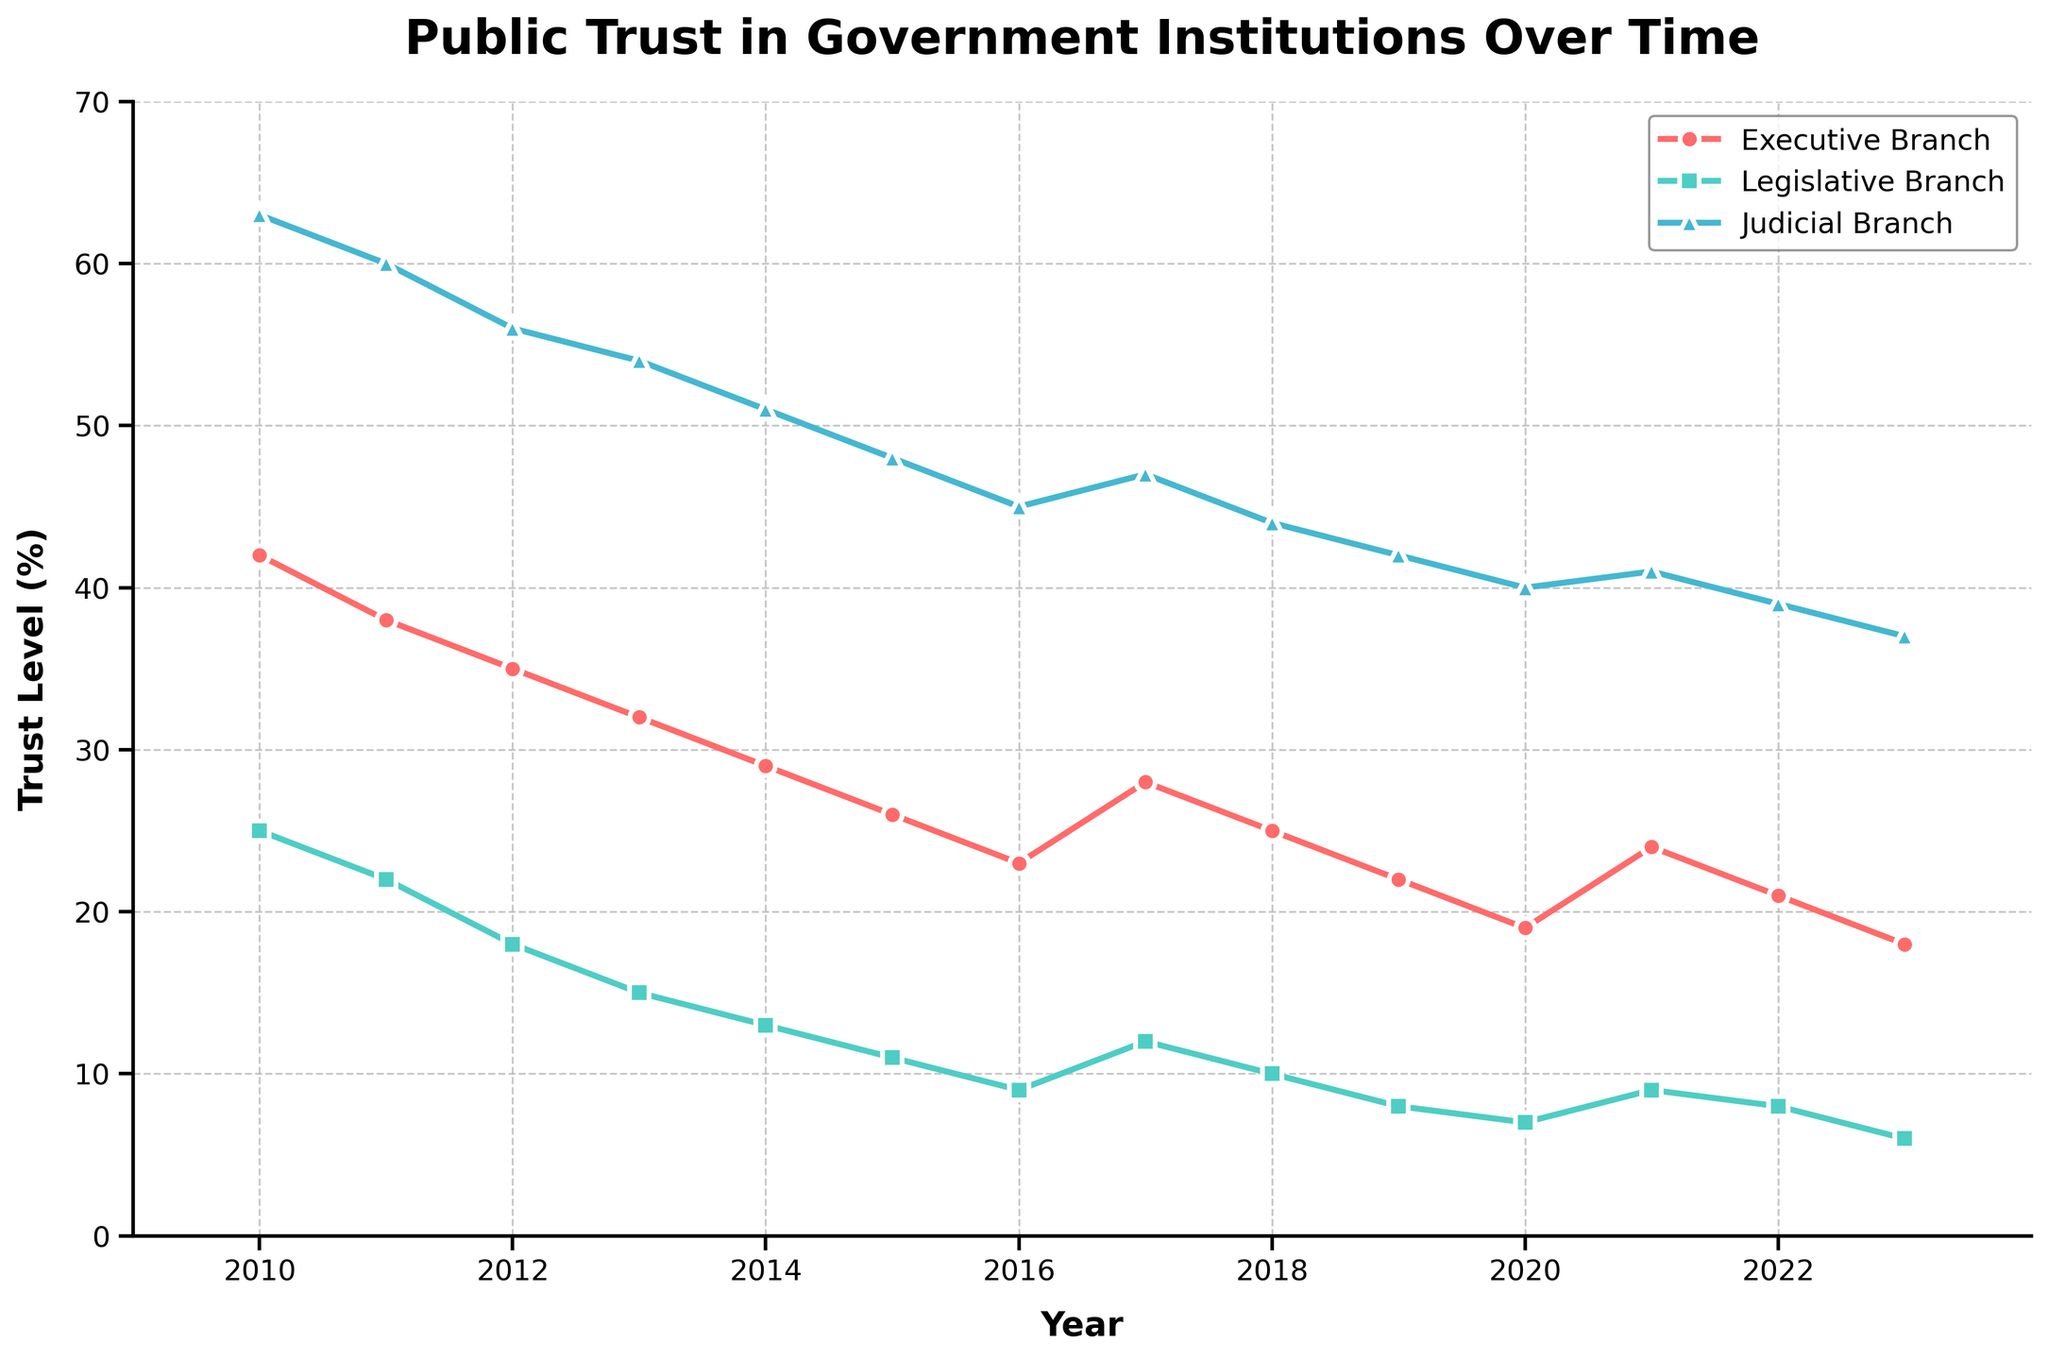What's the overall trend in public trust for the Legislative Branch from 2010 to 2023? From the line chart, we can observe that the level of public trust in the Legislative Branch consistently decreases from 2010 to 2023. The graph shows a downward sloping line, indicating a decline in public trust.
Answer: Decreasing In what year did the Executive Branch experience the largest percentage drop in public trust compared to the previous year? To find the largest percentage drop, we compute the percentage difference between each consecutive year's trust level and identify the biggest change. The percentage drop from 2010 to 2011 is (42-38)/42 ≈ 9.52%. From 2011 to 2012, it is (38-35)/38 ≈ 7.89%. The biggest drop is from 2010 to 2011 with approximately 9.52%.
Answer: 2011 By how many percentage points did public trust in the Judicial Branch decline from 2010 to 2023? To find the decline in percentage points, subtract the 2023 value from the 2010 value for the Judicial Branch. This is 63 - 37 = 26 percentage points.
Answer: 26 Compare the trust levels of the Executive and Judicial Branches in 2020. Which one has higher trust and by how much? From the chart, the trust level for the Executive Branch in 2020 is 19%, and for the Judicial Branch, it is 40%. Comparing these, the Judicial Branch is higher by 40 - 19 = 21 percentage points.
Answer: Judicial by 21 Which branch consistently had the highest public trust levels from 2010 to 2023? Observing the lines on the graph, the line for the Judicial Branch is consistently above the lines for the Executive and Legislative Branches for all years from 2010 to 2023.
Answer: Judicial Branch What is the average trust level in the Executive Branch over the entire period? To find the average trust level, sum the values for the Executive Branch from 2010 to 2023 and divide by the number of years. The sum is 42 + 38 + 35 + 32 + 29 + 26 + 23 + 28 + 25 + 22 + 19 + 24 + 21 + 18 = 382. There are 14 years, so the average is 382/14 ≈ 27.29%.
Answer: 27.29% Identify any year(s) where the trust levels of the Executive and Legislative Branches were equal. From the graph, none of the data points for the Executive and Legislative Branches' trust levels are equal in any given year from 2010 to 2023.
Answer: None In which time period did the Legislative Branch surpass its trust levels in 2017? In 2017, the trust level for the Legislative Branch is 12%. Checking the chart, the trust levels for the Legislative Branch surpass 12% before 2017 around 2010 to 2014.
Answer: 2010 to 2014 How many times did the trust level for the Executive Branch exceed 30% during the period? By looking at the plotted points, the trust level exceeded 30% for the Executive Branch from 2010 to 2013. There are 4 instances: 2010, 2011, 2012, and 2013.
Answer: 4 By what percentage did public trust in the Legislative Branch change from 2017 to 2020? In 2017, the trust level was 12%, and in 2020 it was 7%. The percentage change is calculated by ((7 - 12) / 12) * 100 ≈ -41.67%.
Answer: -41.67% 